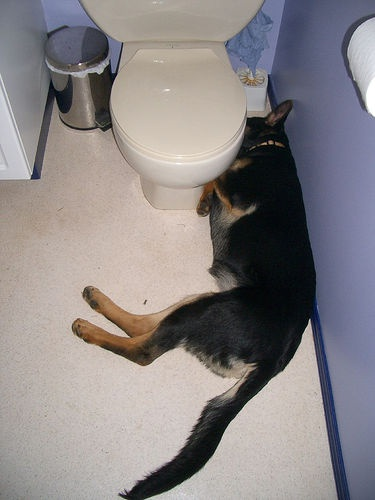Describe the objects in this image and their specific colors. I can see dog in gray, black, and maroon tones and toilet in gray, darkgray, and lightgray tones in this image. 